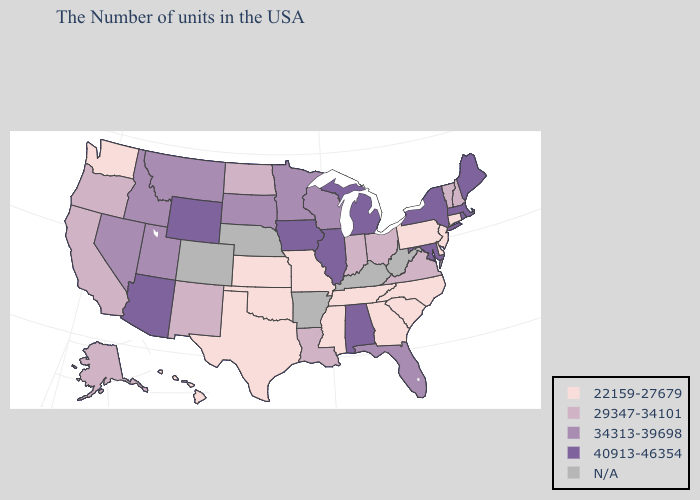Name the states that have a value in the range 40913-46354?
Give a very brief answer. Maine, Massachusetts, Rhode Island, New York, Maryland, Michigan, Alabama, Illinois, Iowa, Wyoming, Arizona. Does the first symbol in the legend represent the smallest category?
Write a very short answer. Yes. Name the states that have a value in the range 29347-34101?
Be succinct. New Hampshire, Vermont, Virginia, Ohio, Indiana, Louisiana, North Dakota, New Mexico, California, Oregon, Alaska. What is the lowest value in the Northeast?
Give a very brief answer. 22159-27679. What is the lowest value in the Northeast?
Quick response, please. 22159-27679. Name the states that have a value in the range N/A?
Write a very short answer. West Virginia, Kentucky, Arkansas, Nebraska, Colorado. Among the states that border Michigan , does Ohio have the lowest value?
Quick response, please. Yes. Name the states that have a value in the range N/A?
Write a very short answer. West Virginia, Kentucky, Arkansas, Nebraska, Colorado. Does the map have missing data?
Be succinct. Yes. What is the value of Georgia?
Concise answer only. 22159-27679. What is the highest value in the South ?
Give a very brief answer. 40913-46354. What is the value of Washington?
Concise answer only. 22159-27679. 